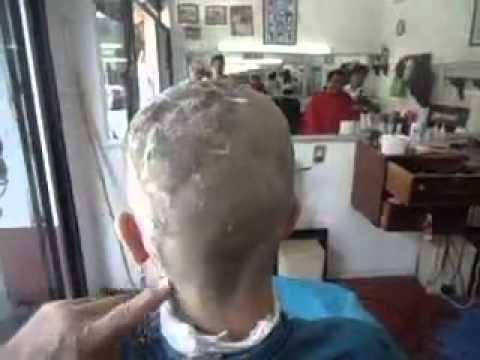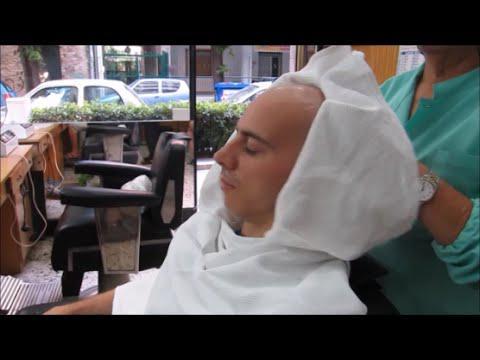The first image is the image on the left, the second image is the image on the right. Considering the images on both sides, is "An image shows a woman with light blonde hair behind an adult male customer." valid? Answer yes or no. No. The first image is the image on the left, the second image is the image on the right. For the images shown, is this caption "The person in the image on the right is covered with a black smock" true? Answer yes or no. No. 